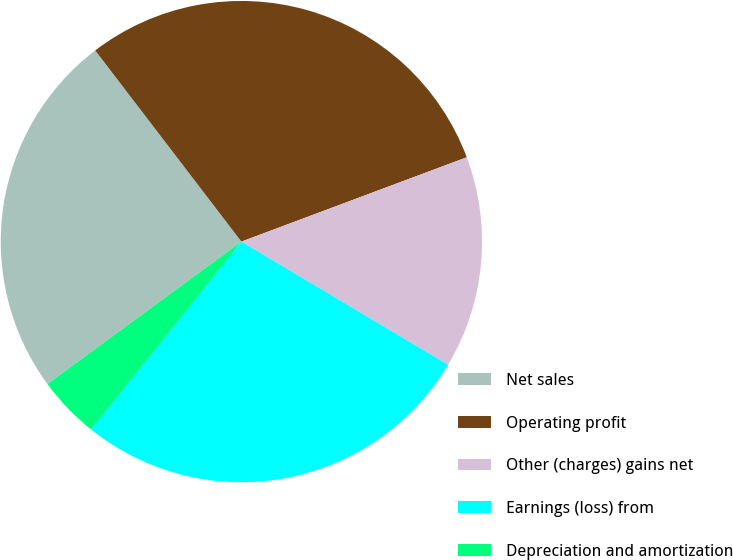Convert chart. <chart><loc_0><loc_0><loc_500><loc_500><pie_chart><fcel>Net sales<fcel>Operating profit<fcel>Other (charges) gains net<fcel>Earnings (loss) from<fcel>Depreciation and amortization<nl><fcel>24.69%<fcel>29.69%<fcel>14.25%<fcel>27.19%<fcel>4.18%<nl></chart> 